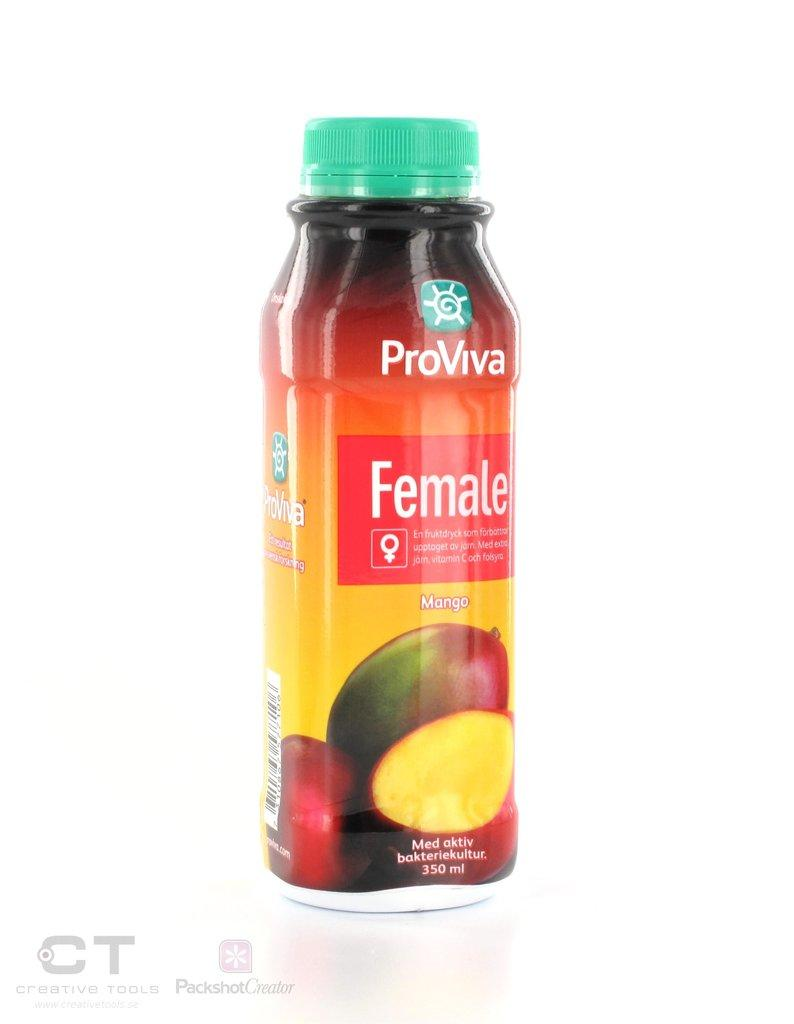What type of bottle is present in the image? There is a mango bottle in the image. How many trains can be seen passing by in the image? There are no trains present in the image; it only features a mango bottle. What do you need to believe in order to see spiders in the image? There is no need to believe in anything to see spiders in the image, as there are no spiders present. 